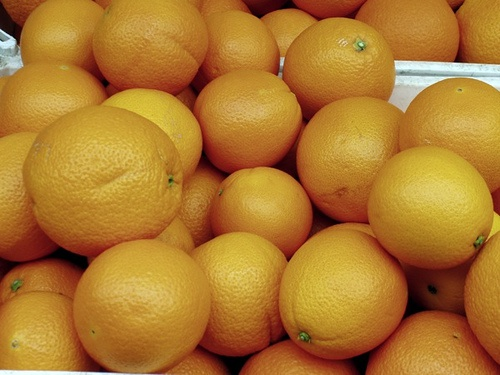Describe the objects in this image and their specific colors. I can see orange in maroon, red, and orange tones, orange in maroon, orange, olive, and tan tones, orange in maroon, red, orange, and gold tones, orange in maroon, gold, olive, orange, and khaki tones, and orange in maroon, red, orange, and tan tones in this image. 